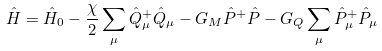<formula> <loc_0><loc_0><loc_500><loc_500>\hat { H } = \hat { H } _ { 0 } - \frac { \chi } { 2 } \sum _ { \mu } \hat { Q } _ { \mu } ^ { + } \hat { Q } _ { \mu } - G _ { M } \hat { P } ^ { + } \hat { P } - G _ { Q } \sum _ { \mu } \hat { P } _ { \mu } ^ { + } \hat { P } _ { \mu }</formula> 